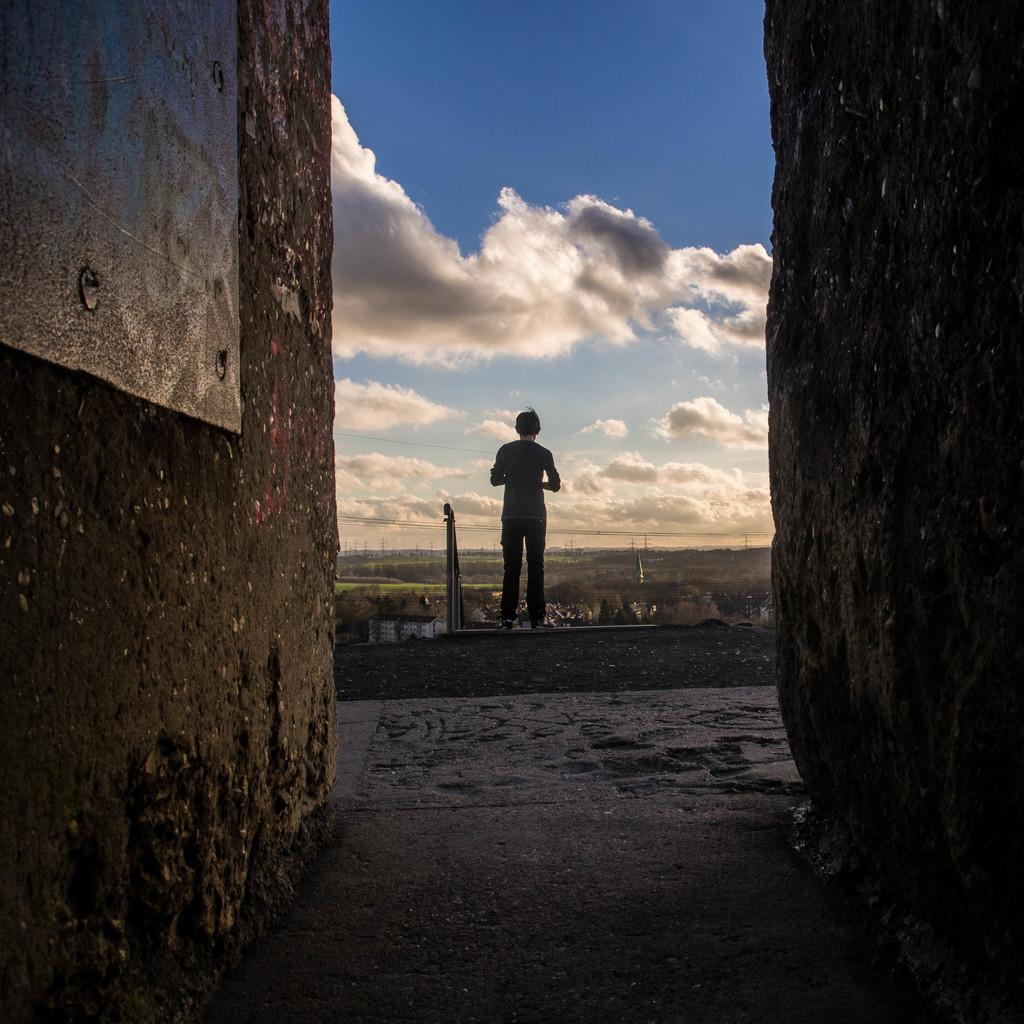What type of surface can be seen in the image? There is ground visible in the image. What structure is present in the image? There is a wall in the image. Who or what is in the image? There is a person in the image. What objects are present in the image? There are poles in the image. What is visible in the background of the image? The sky is visible in the image, and clouds are present in the sky. What type of juice is being served in the image? There is no juice present in the image; it only features a person, poles, a wall, ground, and the sky with clouds. 